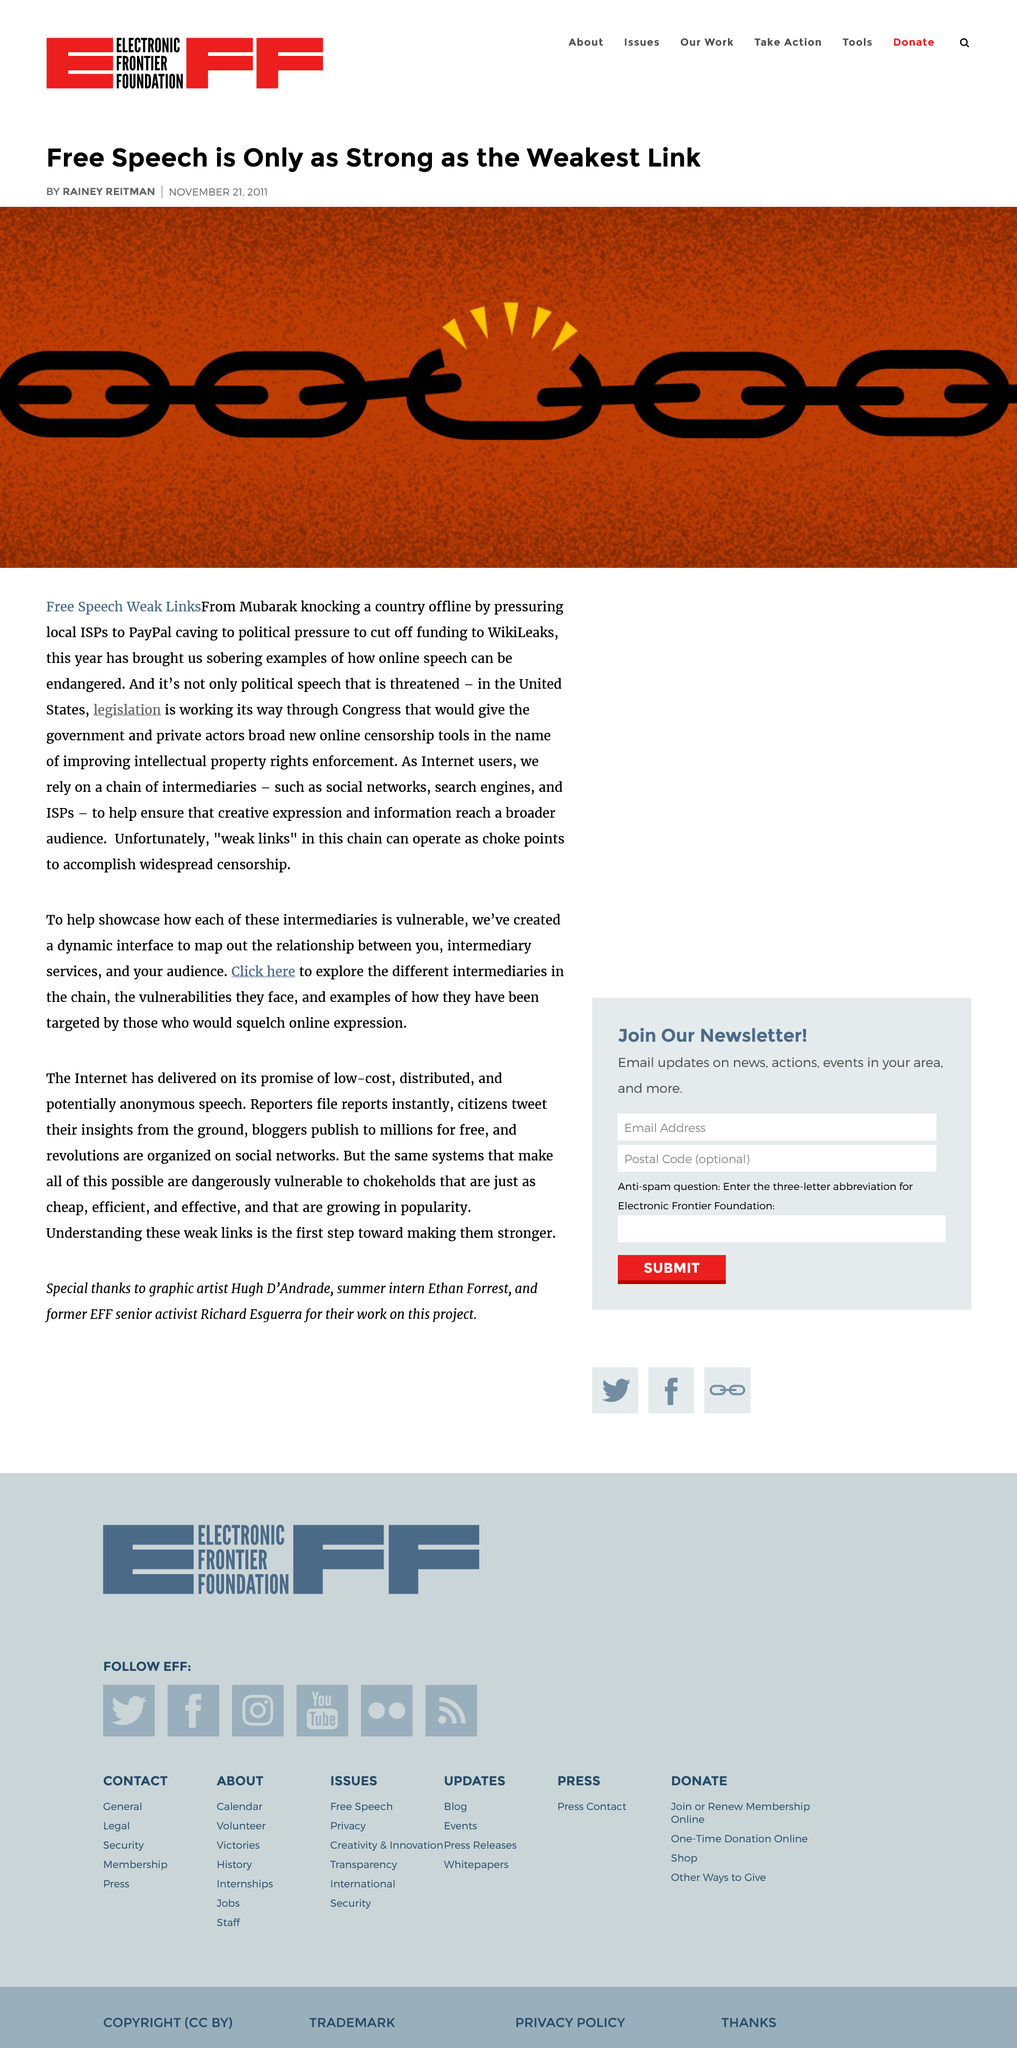Specify some key components in this picture. Internet users rely on a complex network of intermediaries to access the information and services they need online. The article "Free Speech is Only as Strong as the Weakest Link" was written by Rainey Reitman. Current legislation being considered by the United States Congress would grant the government and private actors sweeping new powers of online censorship, supposedly for the purpose of protecting intellectual property rights, but in reality threatening the fundamental right to free speech. 